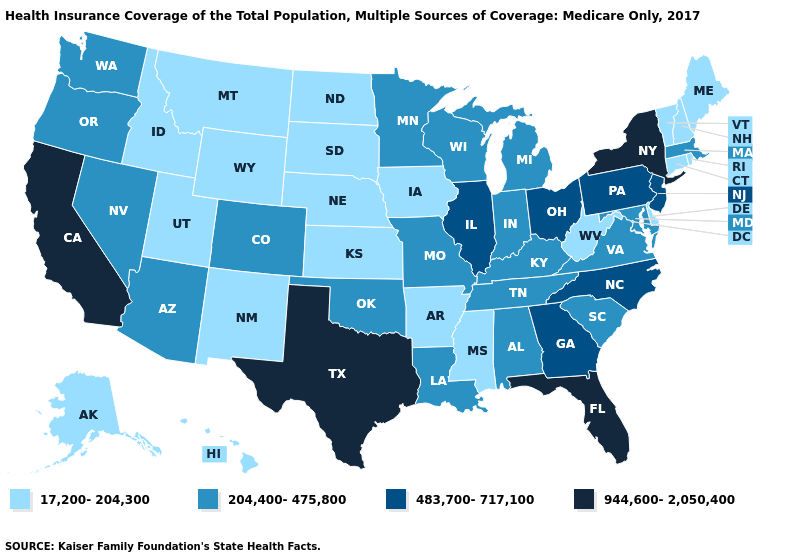Does Illinois have a lower value than Hawaii?
Quick response, please. No. What is the lowest value in the Northeast?
Concise answer only. 17,200-204,300. Name the states that have a value in the range 483,700-717,100?
Answer briefly. Georgia, Illinois, New Jersey, North Carolina, Ohio, Pennsylvania. Does Iowa have the lowest value in the MidWest?
Concise answer only. Yes. Name the states that have a value in the range 204,400-475,800?
Answer briefly. Alabama, Arizona, Colorado, Indiana, Kentucky, Louisiana, Maryland, Massachusetts, Michigan, Minnesota, Missouri, Nevada, Oklahoma, Oregon, South Carolina, Tennessee, Virginia, Washington, Wisconsin. What is the highest value in the USA?
Be succinct. 944,600-2,050,400. Which states have the highest value in the USA?
Quick response, please. California, Florida, New York, Texas. Name the states that have a value in the range 17,200-204,300?
Be succinct. Alaska, Arkansas, Connecticut, Delaware, Hawaii, Idaho, Iowa, Kansas, Maine, Mississippi, Montana, Nebraska, New Hampshire, New Mexico, North Dakota, Rhode Island, South Dakota, Utah, Vermont, West Virginia, Wyoming. Does the first symbol in the legend represent the smallest category?
Give a very brief answer. Yes. What is the highest value in states that border Delaware?
Short answer required. 483,700-717,100. Does New York have the lowest value in the Northeast?
Be succinct. No. Which states have the highest value in the USA?
Quick response, please. California, Florida, New York, Texas. What is the lowest value in the USA?
Give a very brief answer. 17,200-204,300. Name the states that have a value in the range 944,600-2,050,400?
Be succinct. California, Florida, New York, Texas. Does Utah have the lowest value in the West?
Quick response, please. Yes. 